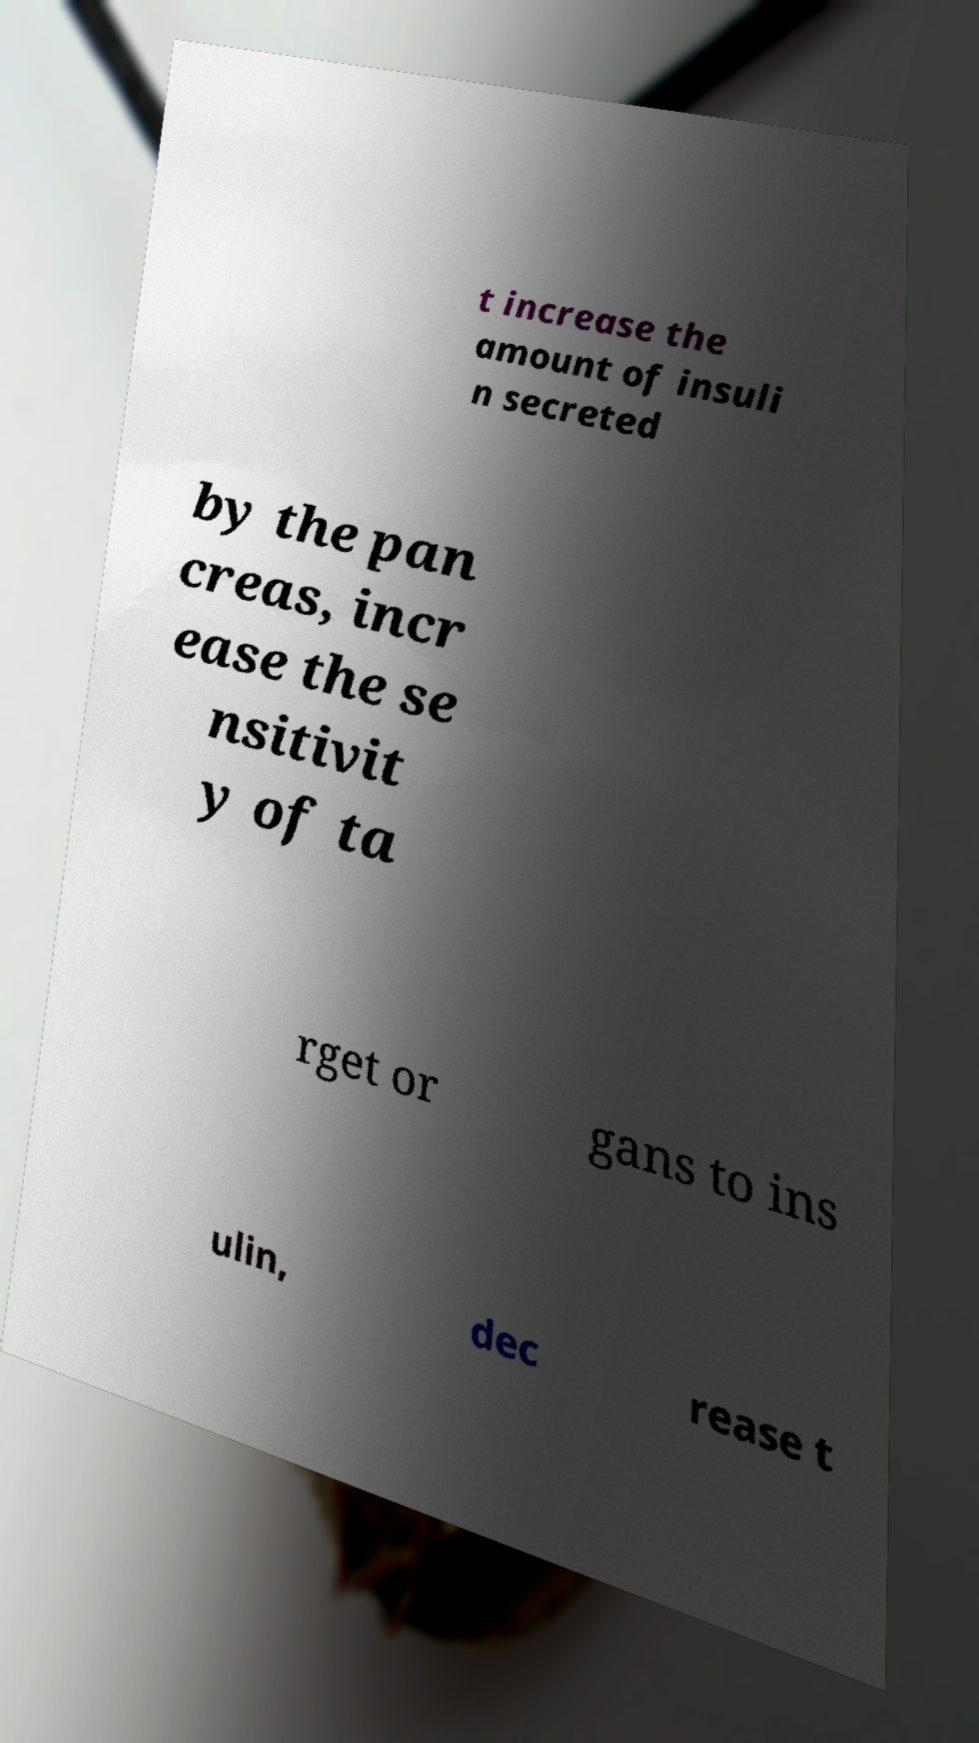Please read and relay the text visible in this image. What does it say? t increase the amount of insuli n secreted by the pan creas, incr ease the se nsitivit y of ta rget or gans to ins ulin, dec rease t 